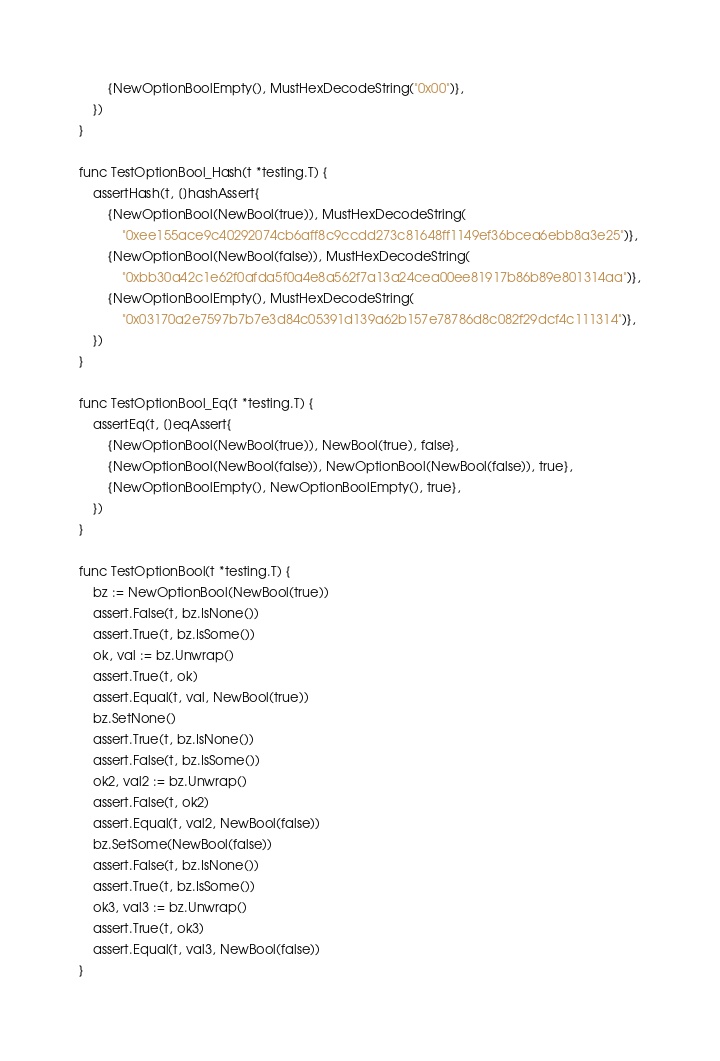Convert code to text. <code><loc_0><loc_0><loc_500><loc_500><_Go_>		{NewOptionBoolEmpty(), MustHexDecodeString("0x00")},
	})
}

func TestOptionBool_Hash(t *testing.T) {
	assertHash(t, []hashAssert{
		{NewOptionBool(NewBool(true)), MustHexDecodeString(
			"0xee155ace9c40292074cb6aff8c9ccdd273c81648ff1149ef36bcea6ebb8a3e25")},
		{NewOptionBool(NewBool(false)), MustHexDecodeString(
			"0xbb30a42c1e62f0afda5f0a4e8a562f7a13a24cea00ee81917b86b89e801314aa")},
		{NewOptionBoolEmpty(), MustHexDecodeString(
			"0x03170a2e7597b7b7e3d84c05391d139a62b157e78786d8c082f29dcf4c111314")},
	})
}

func TestOptionBool_Eq(t *testing.T) {
	assertEq(t, []eqAssert{
		{NewOptionBool(NewBool(true)), NewBool(true), false},
		{NewOptionBool(NewBool(false)), NewOptionBool(NewBool(false)), true},
		{NewOptionBoolEmpty(), NewOptionBoolEmpty(), true},
	})
}

func TestOptionBool(t *testing.T) {
	bz := NewOptionBool(NewBool(true))
	assert.False(t, bz.IsNone())
	assert.True(t, bz.IsSome())
	ok, val := bz.Unwrap()
	assert.True(t, ok)
	assert.Equal(t, val, NewBool(true))
	bz.SetNone()
	assert.True(t, bz.IsNone())
	assert.False(t, bz.IsSome())
	ok2, val2 := bz.Unwrap()
	assert.False(t, ok2)
	assert.Equal(t, val2, NewBool(false))
	bz.SetSome(NewBool(false))
	assert.False(t, bz.IsNone())
	assert.True(t, bz.IsSome())
	ok3, val3 := bz.Unwrap()
	assert.True(t, ok3)
	assert.Equal(t, val3, NewBool(false))
}
</code> 